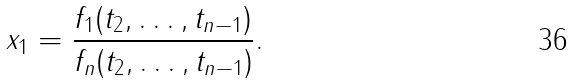<formula> <loc_0><loc_0><loc_500><loc_500>x _ { 1 } = { \frac { f _ { 1 } ( t _ { 2 } , \dots , t _ { n - 1 } ) } { f _ { n } ( t _ { 2 } , \dots , t _ { n - 1 } ) } } .</formula> 